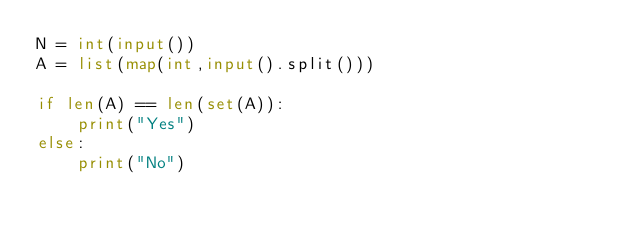<code> <loc_0><loc_0><loc_500><loc_500><_Python_>N = int(input())
A = list(map(int,input().split()))

if len(A) == len(set(A)):
    print("Yes")
else:
    print("No")


</code> 